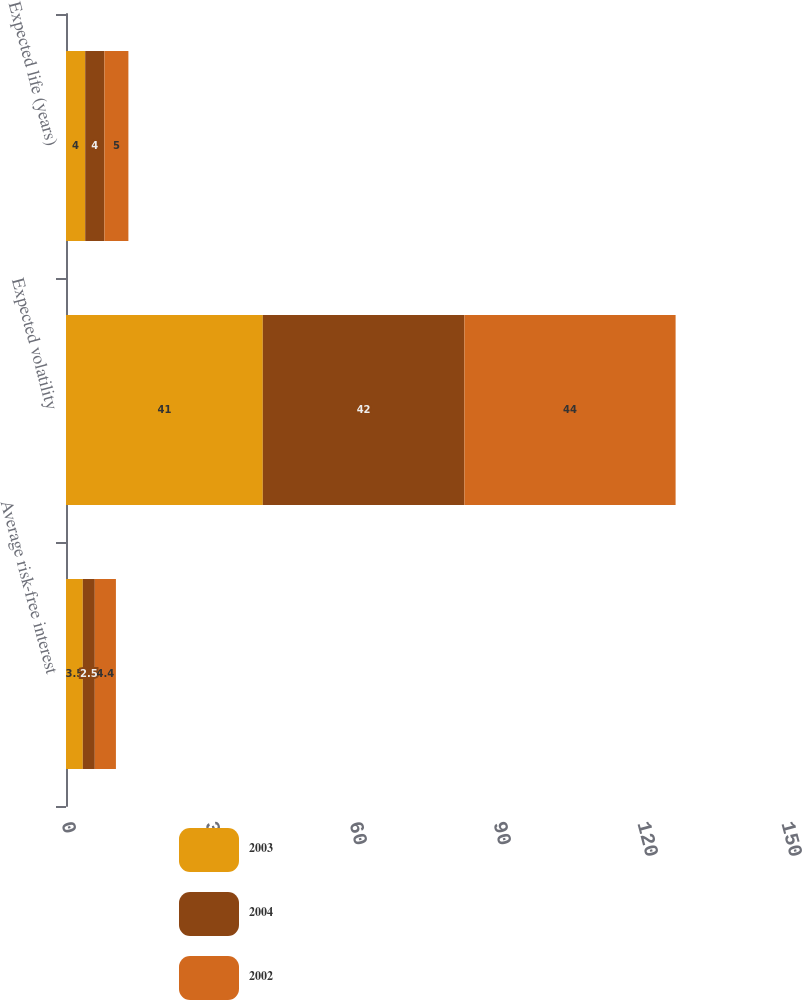Convert chart to OTSL. <chart><loc_0><loc_0><loc_500><loc_500><stacked_bar_chart><ecel><fcel>Average risk-free interest<fcel>Expected volatility<fcel>Expected life (years)<nl><fcel>2003<fcel>3.5<fcel>41<fcel>4<nl><fcel>2004<fcel>2.5<fcel>42<fcel>4<nl><fcel>2002<fcel>4.4<fcel>44<fcel>5<nl></chart> 